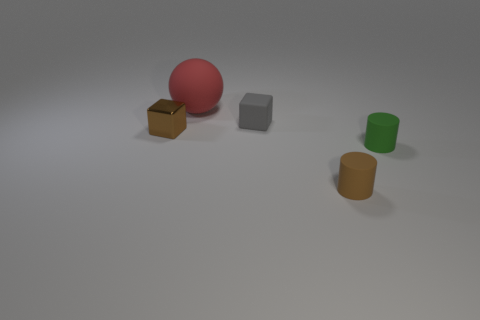Add 2 brown rubber objects. How many objects exist? 7 Subtract all cylinders. How many objects are left? 3 Subtract 1 cylinders. How many cylinders are left? 1 Subtract all brown cubes. How many cubes are left? 1 Subtract all tiny green objects. Subtract all brown shiny blocks. How many objects are left? 3 Add 4 tiny green things. How many tiny green things are left? 5 Add 3 small brown metallic cubes. How many small brown metallic cubes exist? 4 Subtract 1 green cylinders. How many objects are left? 4 Subtract all gray cylinders. Subtract all blue cubes. How many cylinders are left? 2 Subtract all yellow cylinders. How many brown blocks are left? 1 